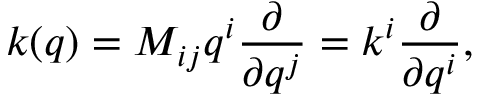Convert formula to latex. <formula><loc_0><loc_0><loc_500><loc_500>k ( q ) = M _ { i j } q ^ { i } { \frac { \partial } { \partial q ^ { j } } } = k ^ { i } { \frac { \partial } { \partial q ^ { i } } } ,</formula> 